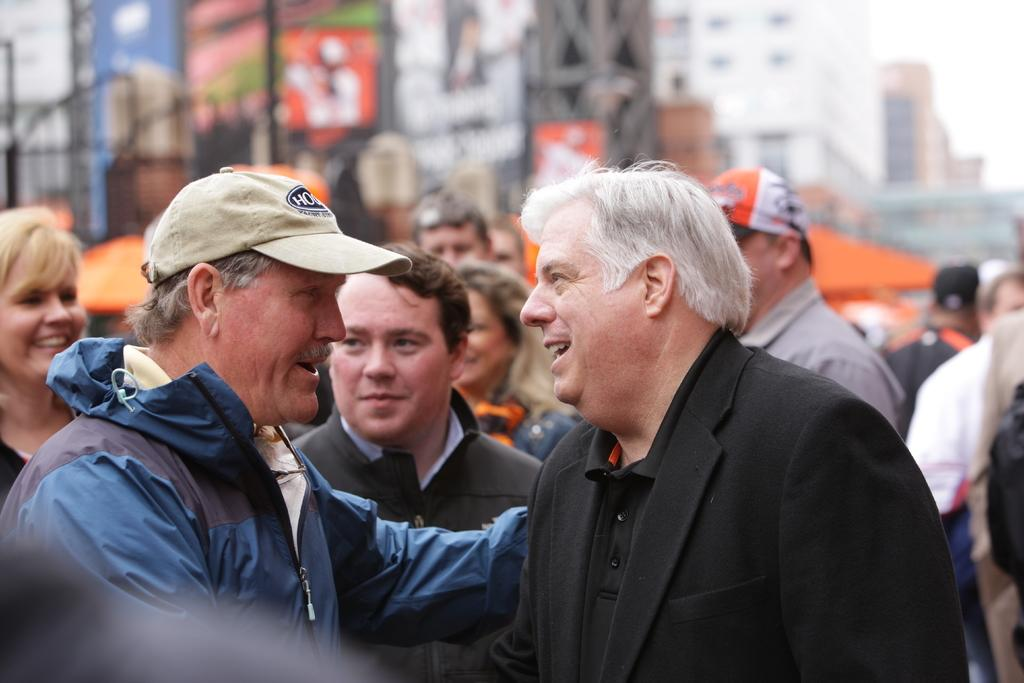What are the two persons in the image doing? The two persons are holding each other in the image. What activity are the two persons engaged in? The two persons are talking in the image. Can you describe the presence of other people in the image? Yes, there are other persons in the image. What type of structures can be seen in the image? There are buildings in the image. What color is the mitten that the snake is wearing in the image? There is no mitten or snake present in the image. What numerical value is associated with the image? The provided facts do not mention any numerical value associated with the image. 